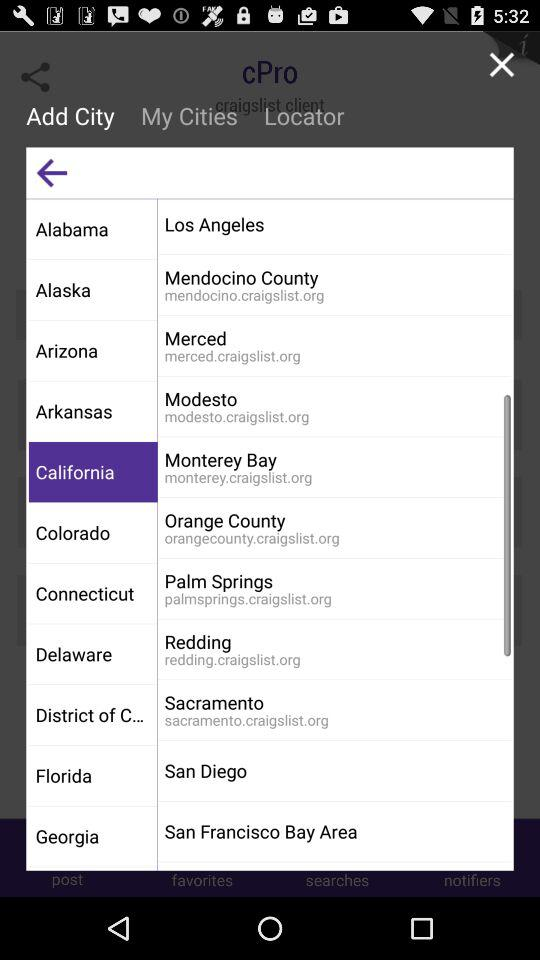What is the selected city? The selected city is California. 